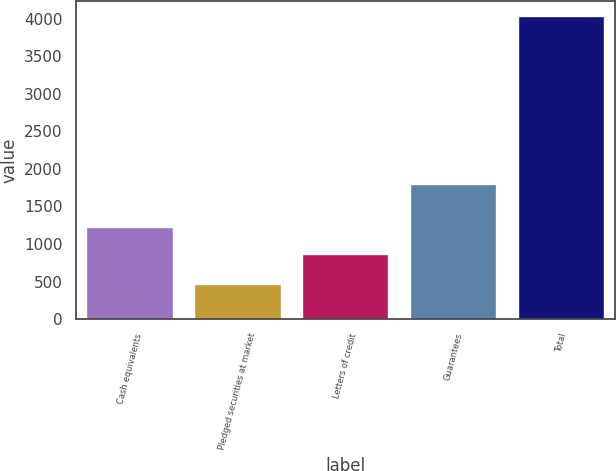<chart> <loc_0><loc_0><loc_500><loc_500><bar_chart><fcel>Cash equivalents<fcel>Pledged securities at market<fcel>Letters of credit<fcel>Guarantees<fcel>Total<nl><fcel>1226.1<fcel>470<fcel>869<fcel>1803<fcel>4041<nl></chart> 